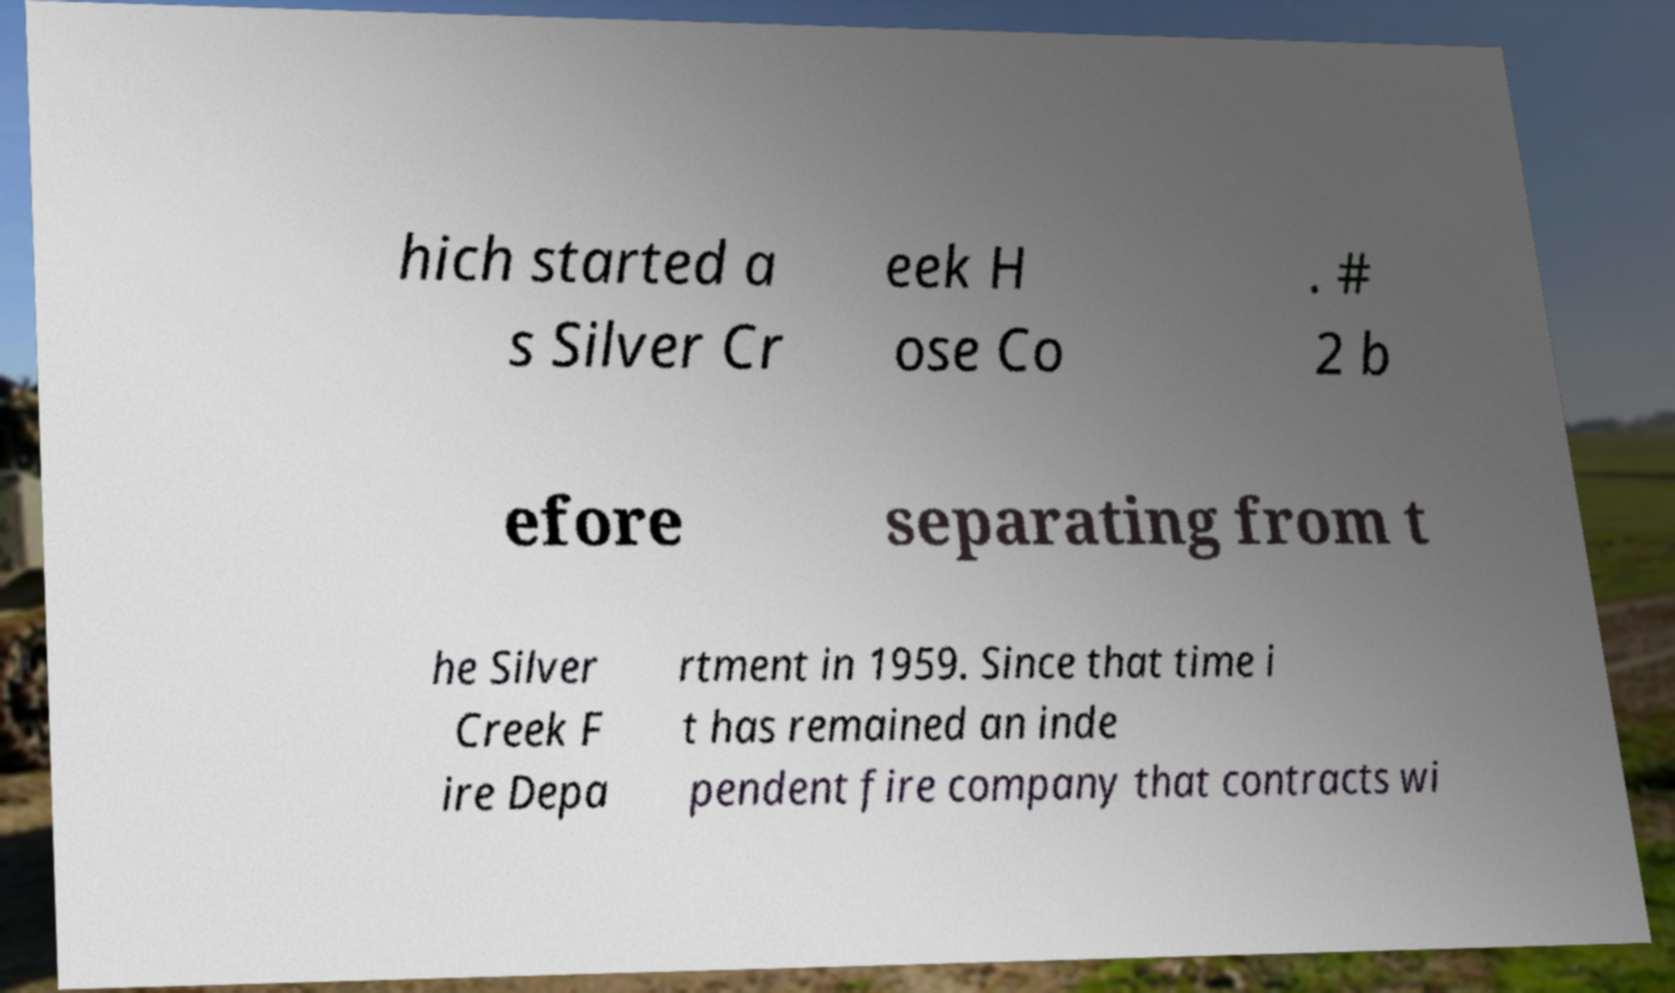There's text embedded in this image that I need extracted. Can you transcribe it verbatim? hich started a s Silver Cr eek H ose Co . # 2 b efore separating from t he Silver Creek F ire Depa rtment in 1959. Since that time i t has remained an inde pendent fire company that contracts wi 